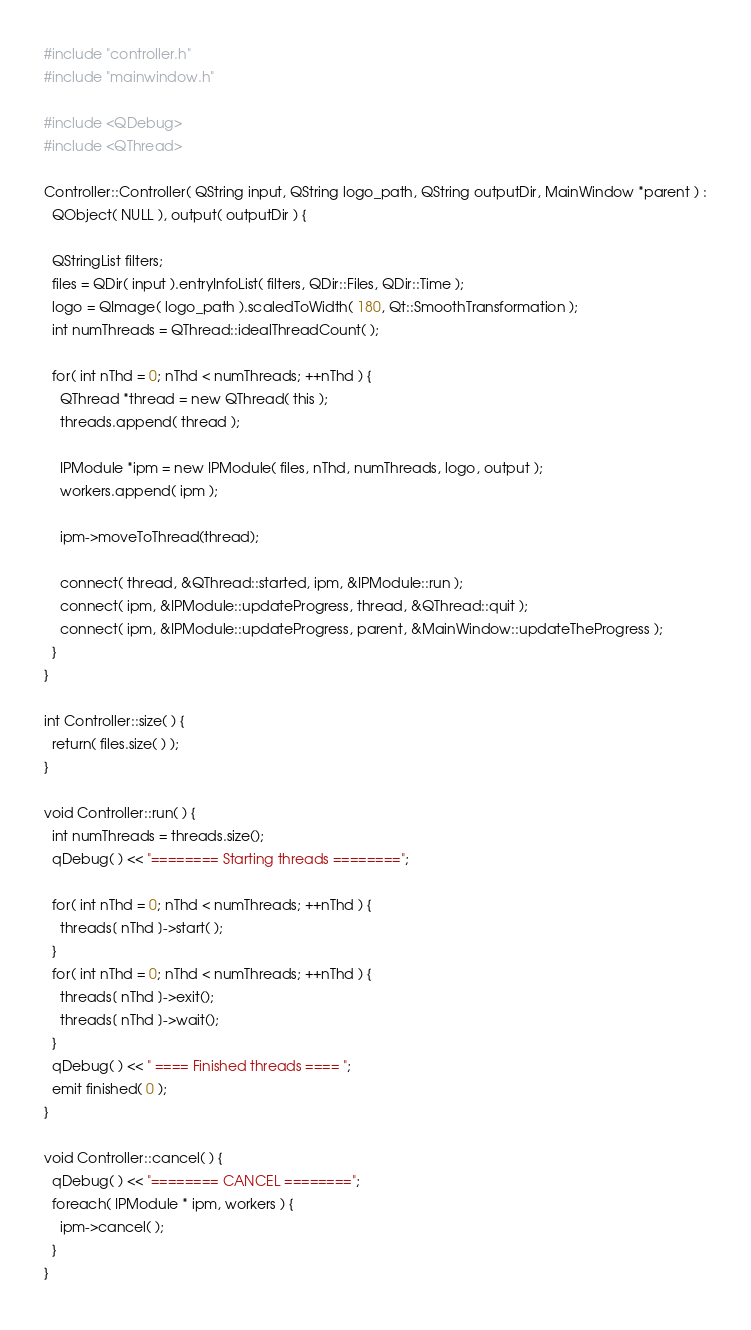Convert code to text. <code><loc_0><loc_0><loc_500><loc_500><_C++_>#include "controller.h"
#include "mainwindow.h"

#include <QDebug>
#include <QThread>

Controller::Controller( QString input, QString logo_path, QString outputDir, MainWindow *parent ) :
  QObject( NULL ), output( outputDir ) {

  QStringList filters;
  files = QDir( input ).entryInfoList( filters, QDir::Files, QDir::Time );
  logo = QImage( logo_path ).scaledToWidth( 180, Qt::SmoothTransformation );
  int numThreads = QThread::idealThreadCount( );

  for( int nThd = 0; nThd < numThreads; ++nThd ) {
    QThread *thread = new QThread( this );
    threads.append( thread );

    IPModule *ipm = new IPModule( files, nThd, numThreads, logo, output );
    workers.append( ipm );

    ipm->moveToThread(thread);

    connect( thread, &QThread::started, ipm, &IPModule::run );
    connect( ipm, &IPModule::updateProgress, thread, &QThread::quit );
    connect( ipm, &IPModule::updateProgress, parent, &MainWindow::updateTheProgress );
  }
}

int Controller::size( ) {
  return( files.size( ) );
}

void Controller::run( ) {
  int numThreads = threads.size();
  qDebug( ) << "======== Starting threads ========";

  for( int nThd = 0; nThd < numThreads; ++nThd ) {
    threads[ nThd ]->start( );
  }
  for( int nThd = 0; nThd < numThreads; ++nThd ) {
    threads[ nThd ]->exit();
    threads[ nThd ]->wait();
  }
  qDebug( ) << " ==== Finished threads ==== ";
  emit finished( 0 );
}

void Controller::cancel( ) {
  qDebug( ) << "======== CANCEL ========";
  foreach( IPModule * ipm, workers ) {
    ipm->cancel( );
  }
}
</code> 